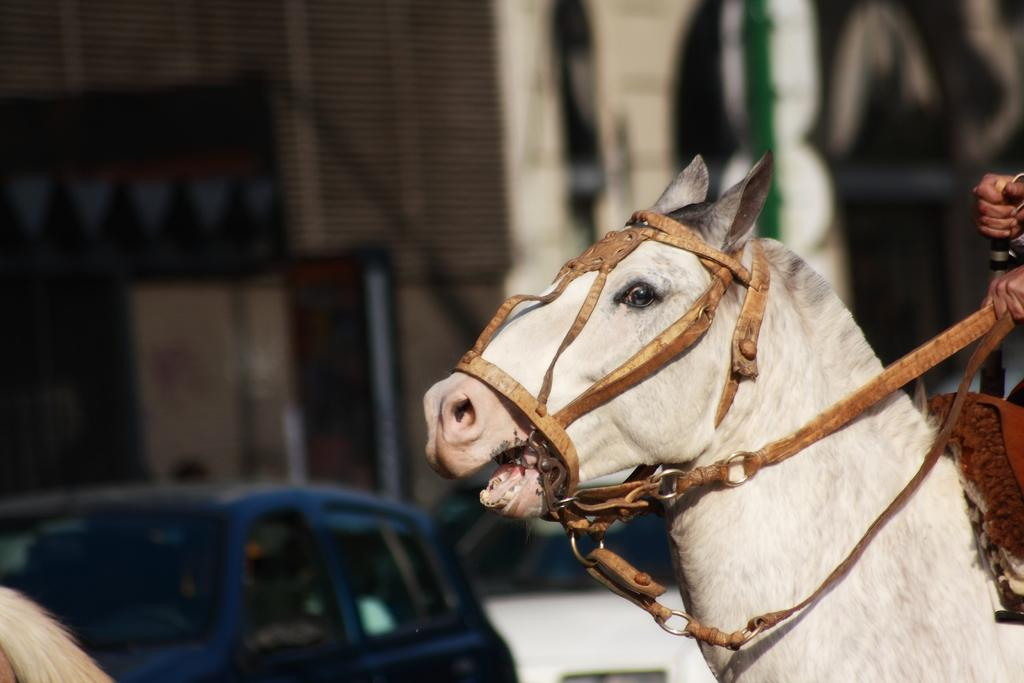What type of animal is on the right side of the image? There is a white color horse with a brown color belt on the right side of the image. What can be seen in the background of the image? There is a vehicle in the background of the image. How would you describe the background of the image? The background of the image is blurred. How many dogs are present in the image? There are no dogs present in the image. What is the weight of the horse in the image? The weight of the horse cannot be determined from the image alone. 